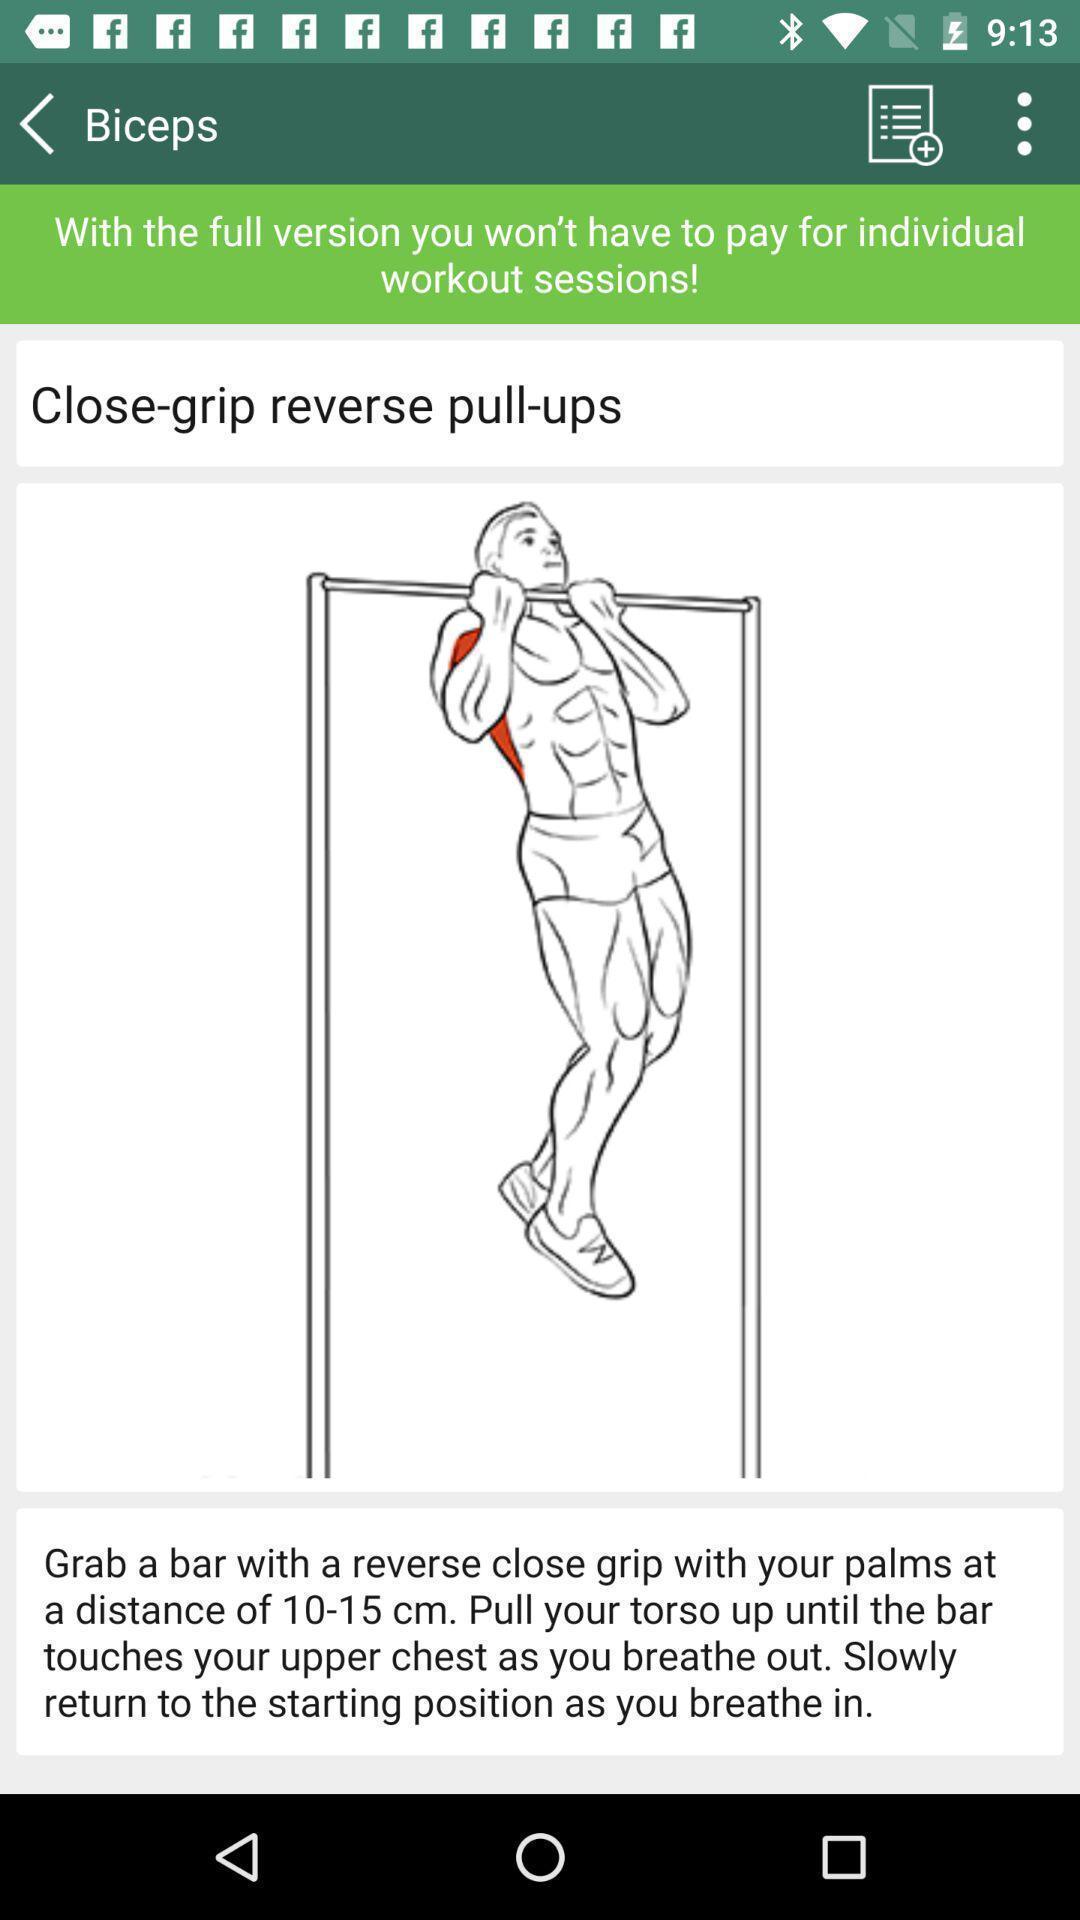Summarize the main components in this picture. Screen showing information about pull-ups in fitness app. 